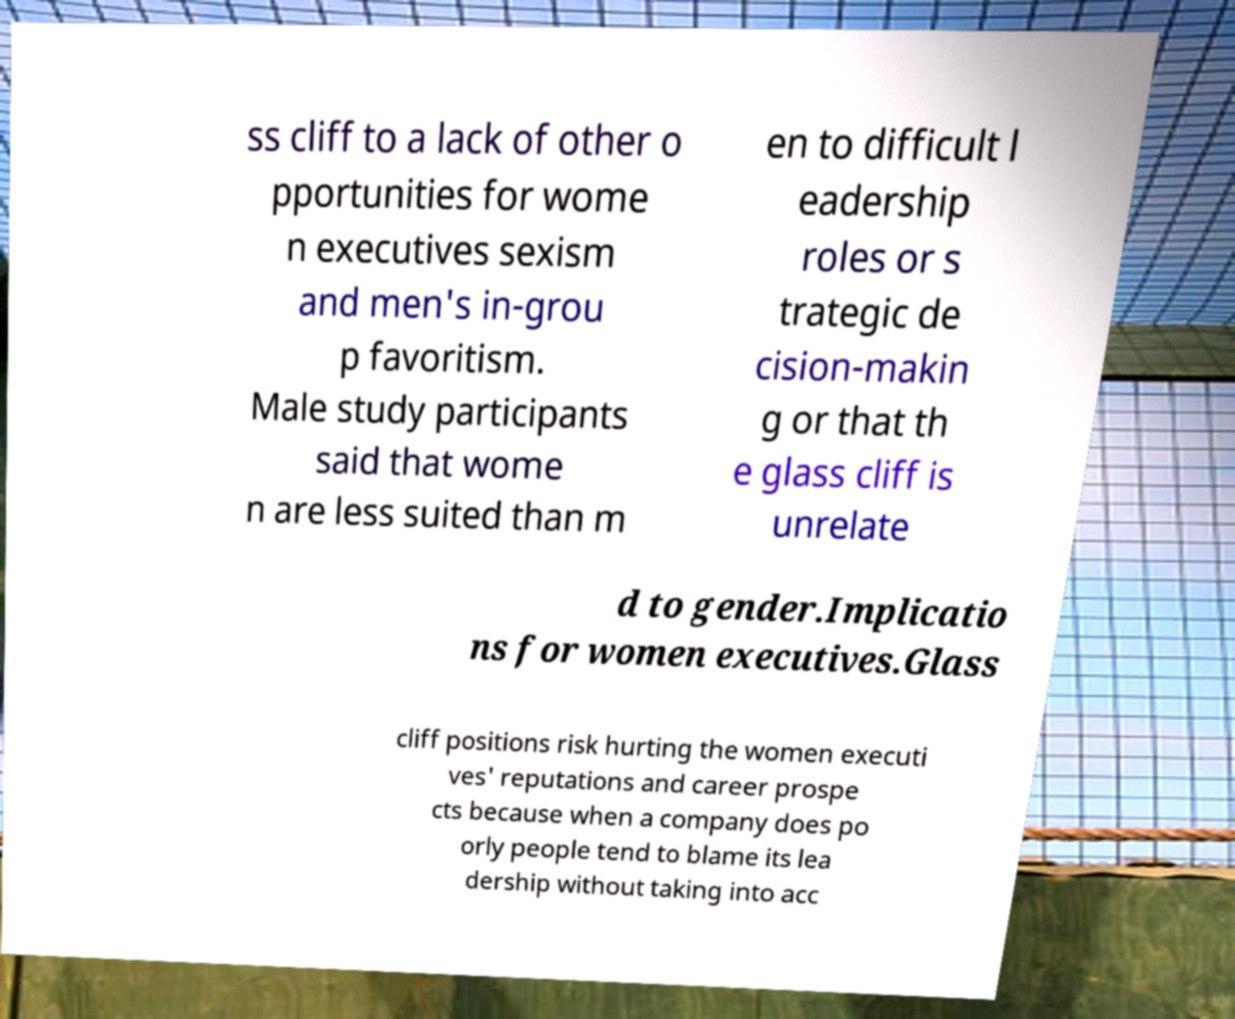Could you assist in decoding the text presented in this image and type it out clearly? ss cliff to a lack of other o pportunities for wome n executives sexism and men's in-grou p favoritism. Male study participants said that wome n are less suited than m en to difficult l eadership roles or s trategic de cision-makin g or that th e glass cliff is unrelate d to gender.Implicatio ns for women executives.Glass cliff positions risk hurting the women executi ves' reputations and career prospe cts because when a company does po orly people tend to blame its lea dership without taking into acc 